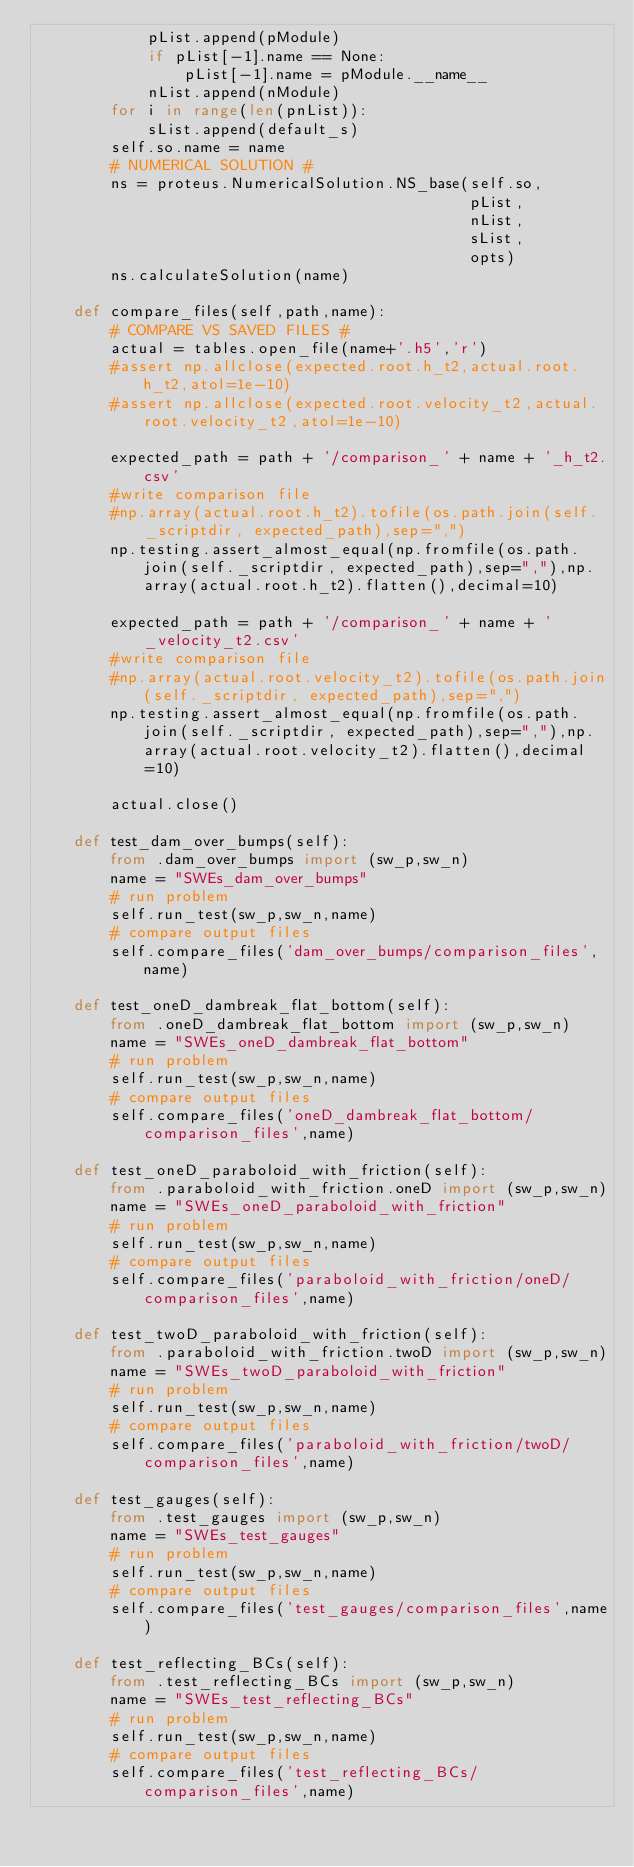<code> <loc_0><loc_0><loc_500><loc_500><_Python_>            pList.append(pModule)
            if pList[-1].name == None:
                pList[-1].name = pModule.__name__
            nList.append(nModule)
        for i in range(len(pnList)):
            sList.append(default_s)
        self.so.name = name
        # NUMERICAL SOLUTION #
        ns = proteus.NumericalSolution.NS_base(self.so,
                                               pList,
                                               nList,
                                               sList,
                                               opts)
        ns.calculateSolution(name)

    def compare_files(self,path,name):
        # COMPARE VS SAVED FILES #
        actual = tables.open_file(name+'.h5','r')
        #assert np.allclose(expected.root.h_t2,actual.root.h_t2,atol=1e-10)
        #assert np.allclose(expected.root.velocity_t2,actual.root.velocity_t2,atol=1e-10)

        expected_path = path + '/comparison_' + name + '_h_t2.csv'
        #write comparison file
        #np.array(actual.root.h_t2).tofile(os.path.join(self._scriptdir, expected_path),sep=",")
        np.testing.assert_almost_equal(np.fromfile(os.path.join(self._scriptdir, expected_path),sep=","),np.array(actual.root.h_t2).flatten(),decimal=10)

        expected_path = path + '/comparison_' + name + '_velocity_t2.csv'
        #write comparison file
        #np.array(actual.root.velocity_t2).tofile(os.path.join(self._scriptdir, expected_path),sep=",")
        np.testing.assert_almost_equal(np.fromfile(os.path.join(self._scriptdir, expected_path),sep=","),np.array(actual.root.velocity_t2).flatten(),decimal=10)

        actual.close()

    def test_dam_over_bumps(self):
        from .dam_over_bumps import (sw_p,sw_n)
        name = "SWEs_dam_over_bumps"
        # run problem
        self.run_test(sw_p,sw_n,name)
        # compare output files
        self.compare_files('dam_over_bumps/comparison_files',name)

    def test_oneD_dambreak_flat_bottom(self):
        from .oneD_dambreak_flat_bottom import (sw_p,sw_n)
        name = "SWEs_oneD_dambreak_flat_bottom"
        # run problem
        self.run_test(sw_p,sw_n,name)
        # compare output files
        self.compare_files('oneD_dambreak_flat_bottom/comparison_files',name)

    def test_oneD_paraboloid_with_friction(self):
        from .paraboloid_with_friction.oneD import (sw_p,sw_n)
        name = "SWEs_oneD_paraboloid_with_friction"
        # run problem
        self.run_test(sw_p,sw_n,name)
        # compare output files
        self.compare_files('paraboloid_with_friction/oneD/comparison_files',name)

    def test_twoD_paraboloid_with_friction(self):
        from .paraboloid_with_friction.twoD import (sw_p,sw_n)
        name = "SWEs_twoD_paraboloid_with_friction"
        # run problem
        self.run_test(sw_p,sw_n,name)
        # compare output files
        self.compare_files('paraboloid_with_friction/twoD/comparison_files',name)

    def test_gauges(self):
        from .test_gauges import (sw_p,sw_n)
        name = "SWEs_test_gauges"
        # run problem
        self.run_test(sw_p,sw_n,name)
        # compare output files
        self.compare_files('test_gauges/comparison_files',name)

    def test_reflecting_BCs(self):
        from .test_reflecting_BCs import (sw_p,sw_n)
        name = "SWEs_test_reflecting_BCs"
        # run problem
        self.run_test(sw_p,sw_n,name)
        # compare output files
        self.compare_files('test_reflecting_BCs/comparison_files',name)
</code> 